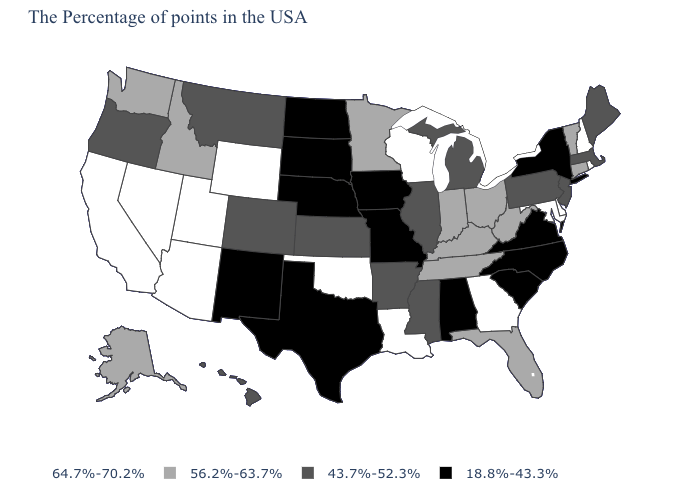What is the value of Illinois?
Quick response, please. 43.7%-52.3%. Among the states that border California , which have the lowest value?
Be succinct. Oregon. Does Maryland have the highest value in the USA?
Be succinct. Yes. What is the value of Utah?
Concise answer only. 64.7%-70.2%. Does Oregon have a higher value than South Dakota?
Write a very short answer. Yes. Does Montana have a lower value than Mississippi?
Answer briefly. No. Does Colorado have the same value as Virginia?
Concise answer only. No. Is the legend a continuous bar?
Be succinct. No. How many symbols are there in the legend?
Keep it brief. 4. Name the states that have a value in the range 43.7%-52.3%?
Be succinct. Maine, Massachusetts, New Jersey, Pennsylvania, Michigan, Illinois, Mississippi, Arkansas, Kansas, Colorado, Montana, Oregon, Hawaii. What is the value of South Carolina?
Be succinct. 18.8%-43.3%. Does the first symbol in the legend represent the smallest category?
Keep it brief. No. Does Mississippi have the highest value in the USA?
Keep it brief. No. How many symbols are there in the legend?
Quick response, please. 4. 